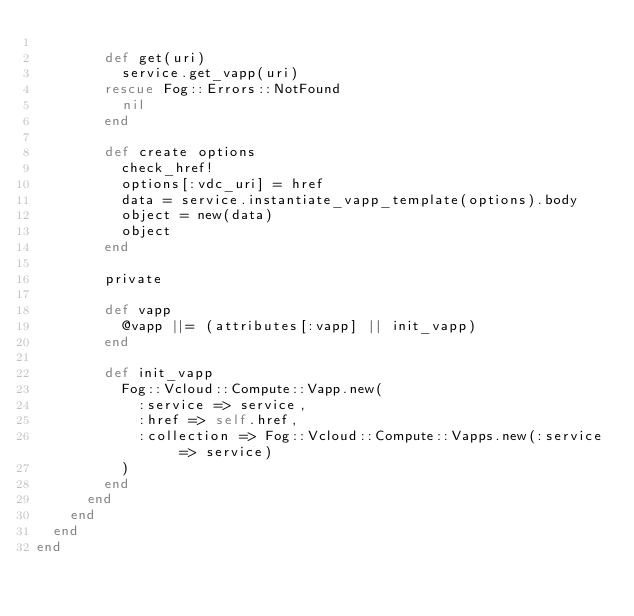Convert code to text. <code><loc_0><loc_0><loc_500><loc_500><_Ruby_>
        def get(uri)
          service.get_vapp(uri)
        rescue Fog::Errors::NotFound
          nil
        end

        def create options
          check_href!
          options[:vdc_uri] = href
          data = service.instantiate_vapp_template(options).body
          object = new(data)
          object
        end

        private

        def vapp
          @vapp ||= (attributes[:vapp] || init_vapp)
        end

        def init_vapp
          Fog::Vcloud::Compute::Vapp.new(
            :service => service,
            :href => self.href,
            :collection => Fog::Vcloud::Compute::Vapps.new(:service => service)
          )
        end
      end
    end
  end
end
</code> 